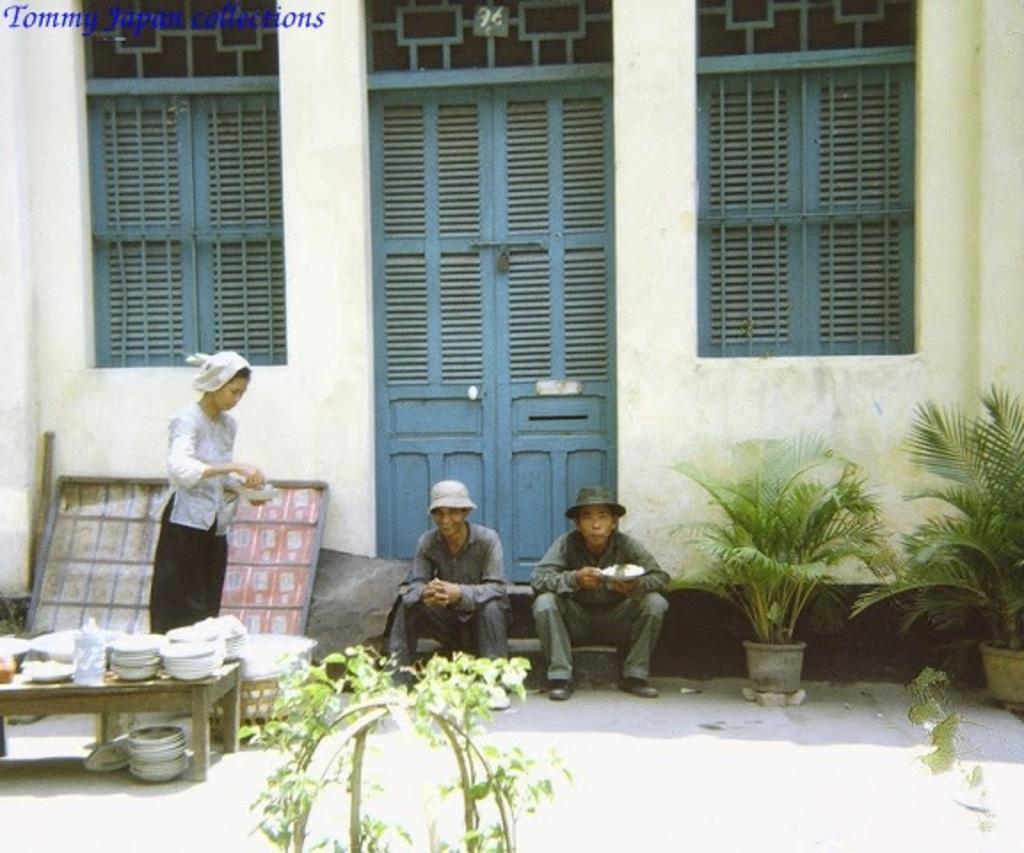In one or two sentences, can you explain what this image depicts? Here in this picture we can see a couple of people sitting on steps over there and both of them are wearing hats on them and behind them we can see a door present and we can see a couple of windows present on the wall over there and beside them we can see a woman standing with a bowl in her hand and in front of her we can see a table, on which we can see all plates and bowls present all over there and we can also see plants on the ground over there. 